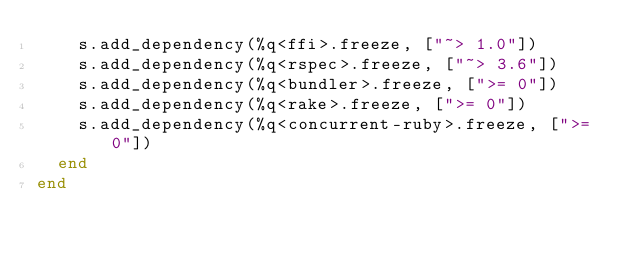Convert code to text. <code><loc_0><loc_0><loc_500><loc_500><_Ruby_>    s.add_dependency(%q<ffi>.freeze, ["~> 1.0"])
    s.add_dependency(%q<rspec>.freeze, ["~> 3.6"])
    s.add_dependency(%q<bundler>.freeze, [">= 0"])
    s.add_dependency(%q<rake>.freeze, [">= 0"])
    s.add_dependency(%q<concurrent-ruby>.freeze, [">= 0"])
  end
end
</code> 